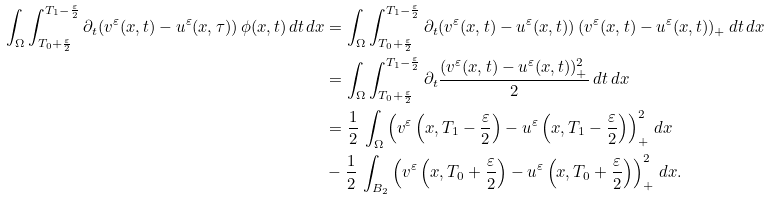<formula> <loc_0><loc_0><loc_500><loc_500>\int _ { \Omega } \int _ { T _ { 0 } + \frac { \varepsilon } { 2 } } ^ { T _ { 1 } - \frac { \varepsilon } { 2 } } \partial _ { t } ( v ^ { \varepsilon } ( x , t ) - u ^ { \varepsilon } ( x , \tau ) ) \, \phi ( x , t ) \, d t \, d x & = \int _ { \Omega } \int _ { T _ { 0 } + \frac { \varepsilon } { 2 } } ^ { T _ { 1 } - \frac { \varepsilon } { 2 } } \partial _ { t } ( v ^ { \varepsilon } ( x , t ) - u ^ { \varepsilon } ( x , t ) ) \, ( v ^ { \varepsilon } ( x , t ) - u ^ { \varepsilon } ( x , t ) ) _ { + } \, d t \, d x \\ & = \int _ { \Omega } \int _ { T _ { 0 } + \frac { \varepsilon } { 2 } } ^ { T _ { 1 } - \frac { \varepsilon } { 2 } } \partial _ { t } \frac { ( v ^ { \varepsilon } ( x , t ) - u ^ { \varepsilon } ( x , t ) ) ^ { 2 } _ { + } } { 2 } \, d t \, d x \\ & = \frac { 1 } { 2 } \, \int _ { \Omega } \left ( v ^ { \varepsilon } \left ( x , T _ { 1 } - \frac { \varepsilon } { 2 } \right ) - u ^ { \varepsilon } \left ( x , T _ { 1 } - \frac { \varepsilon } { 2 } \right ) \right ) ^ { 2 } _ { + } \, d x \\ & - \frac { 1 } { 2 } \, \int _ { B _ { 2 } } \left ( v ^ { \varepsilon } \left ( x , T _ { 0 } + \frac { \varepsilon } { 2 } \right ) - u ^ { \varepsilon } \left ( x , T _ { 0 } + \frac { \varepsilon } { 2 } \right ) \right ) ^ { 2 } _ { + } \, d x .</formula> 